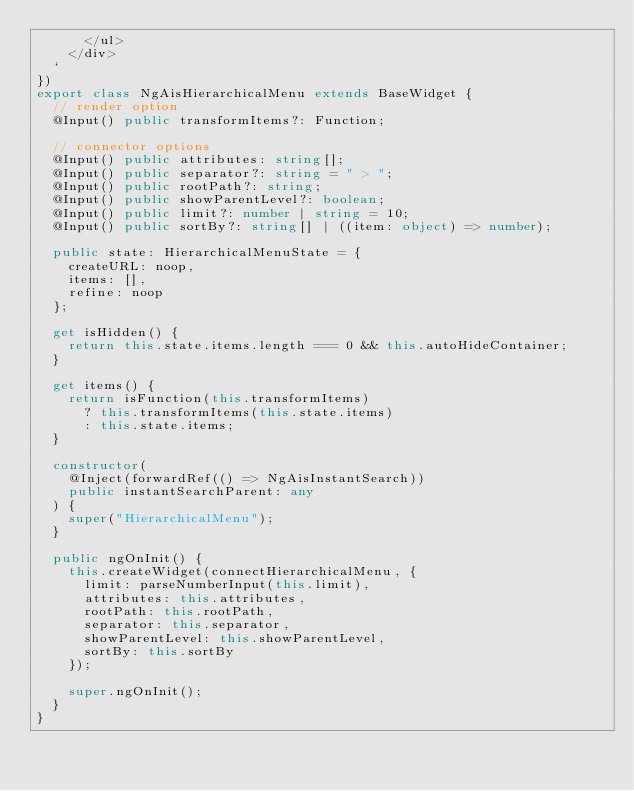<code> <loc_0><loc_0><loc_500><loc_500><_TypeScript_>      </ul>
    </div>
  `
})
export class NgAisHierarchicalMenu extends BaseWidget {
  // render option
  @Input() public transformItems?: Function;

  // connector options
  @Input() public attributes: string[];
  @Input() public separator?: string = " > ";
  @Input() public rootPath?: string;
  @Input() public showParentLevel?: boolean;
  @Input() public limit?: number | string = 10;
  @Input() public sortBy?: string[] | ((item: object) => number);

  public state: HierarchicalMenuState = {
    createURL: noop,
    items: [],
    refine: noop
  };

  get isHidden() {
    return this.state.items.length === 0 && this.autoHideContainer;
  }

  get items() {
    return isFunction(this.transformItems)
      ? this.transformItems(this.state.items)
      : this.state.items;
  }

  constructor(
    @Inject(forwardRef(() => NgAisInstantSearch))
    public instantSearchParent: any
  ) {
    super("HierarchicalMenu");
  }

  public ngOnInit() {
    this.createWidget(connectHierarchicalMenu, {
      limit: parseNumberInput(this.limit),
      attributes: this.attributes,
      rootPath: this.rootPath,
      separator: this.separator,
      showParentLevel: this.showParentLevel,
      sortBy: this.sortBy
    });

    super.ngOnInit();
  }
}
</code> 